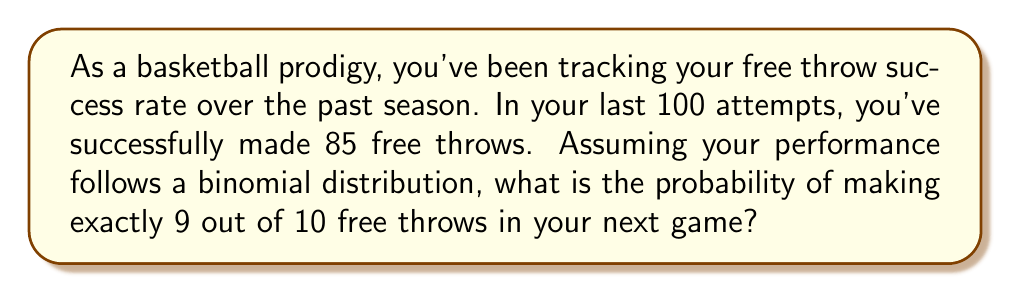Can you answer this question? To solve this problem, we'll use the binomial probability formula and the given statistics:

1. Identify the parameters:
   - $n$ (number of trials) = 10
   - $k$ (number of successes) = 9
   - $p$ (probability of success on a single trial) = 85/100 = 0.85

2. The binomial probability formula is:

   $$P(X = k) = \binom{n}{k} p^k (1-p)^{n-k}$$

3. Calculate the binomial coefficient:
   
   $$\binom{10}{9} = \frac{10!}{9!(10-9)!} = \frac{10!}{9!1!} = 10$$

4. Substitute the values into the formula:

   $$P(X = 9) = 10 \cdot (0.85)^9 \cdot (1-0.85)^{10-9}$$

5. Simplify:
   
   $$P(X = 9) = 10 \cdot (0.85)^9 \cdot (0.15)^1$$

6. Calculate the result:
   
   $$P(X = 9) = 10 \cdot 0.2316 \cdot 0.15 = 0.3474$$

Therefore, the probability of making exactly 9 out of 10 free throws in your next game is approximately 0.3474 or 34.74%.
Answer: 0.3474 